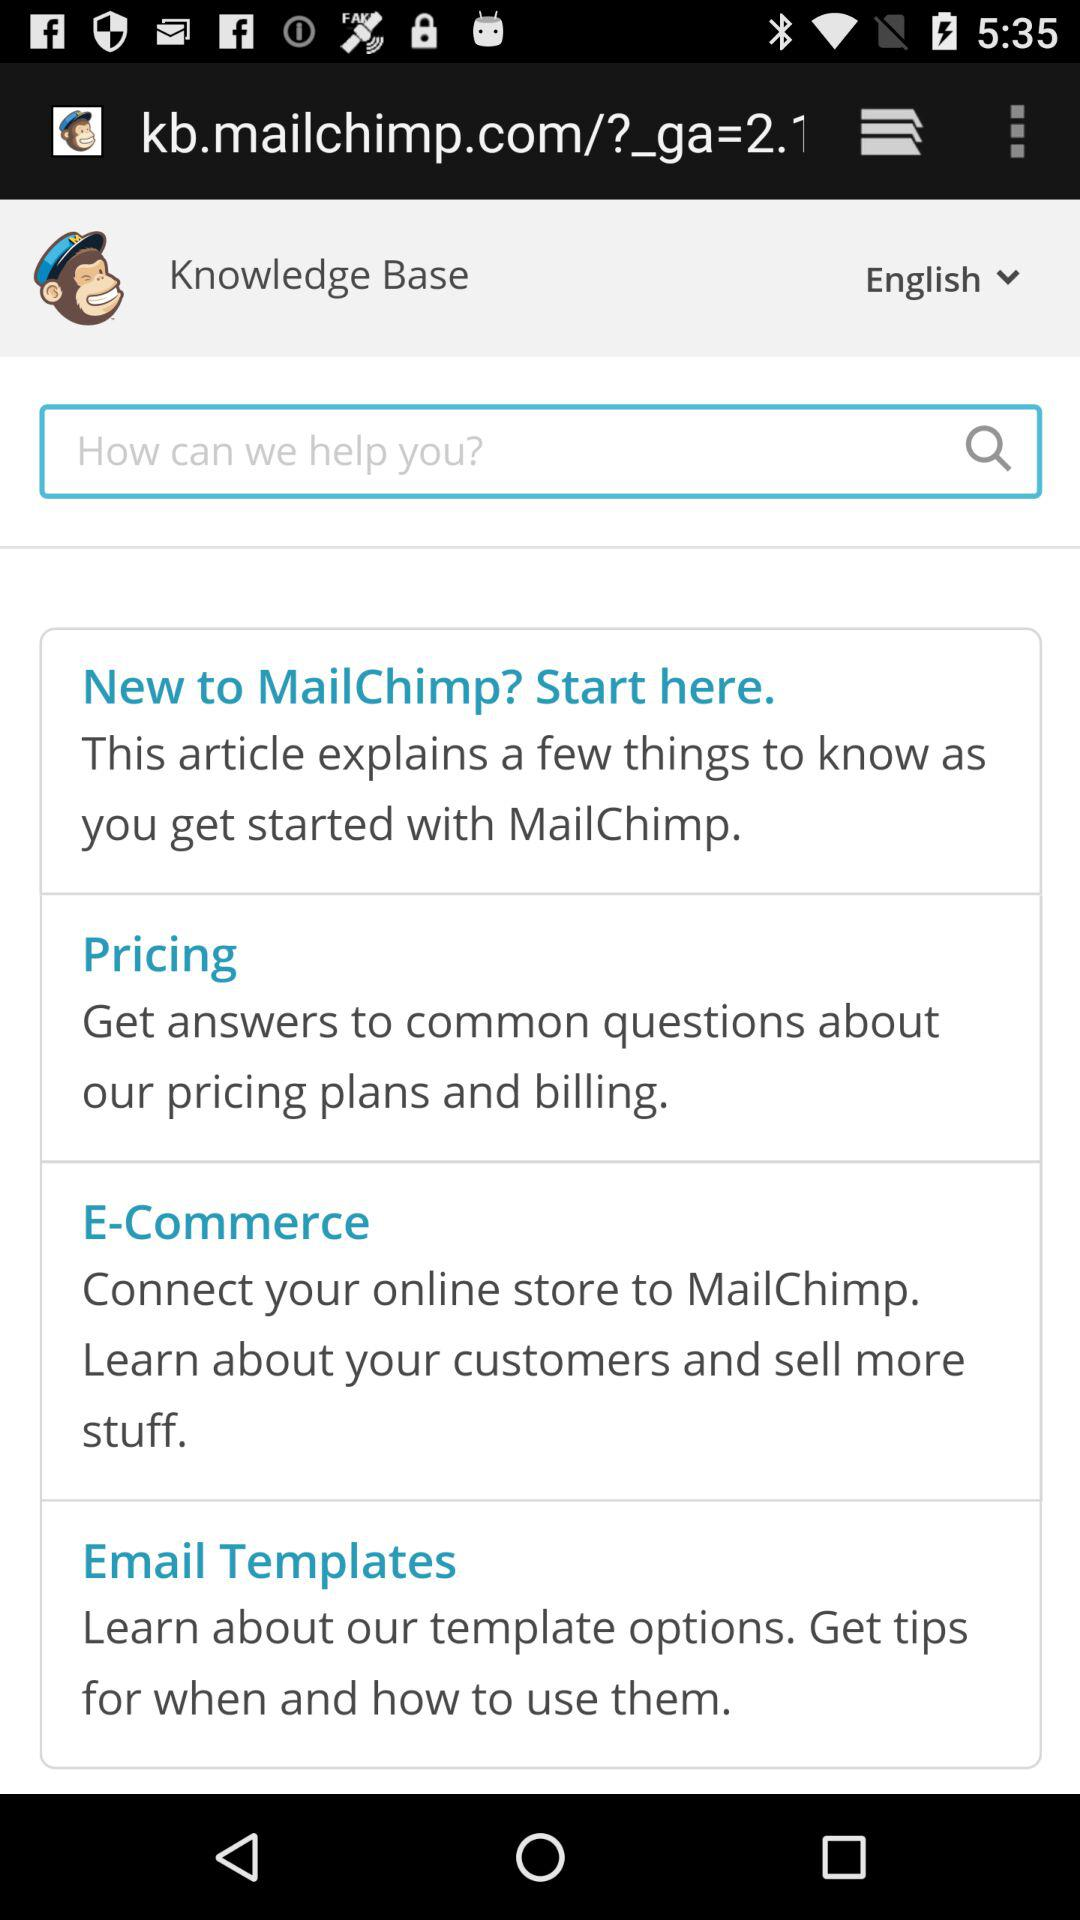What is the selected language? The selected language is "English". 